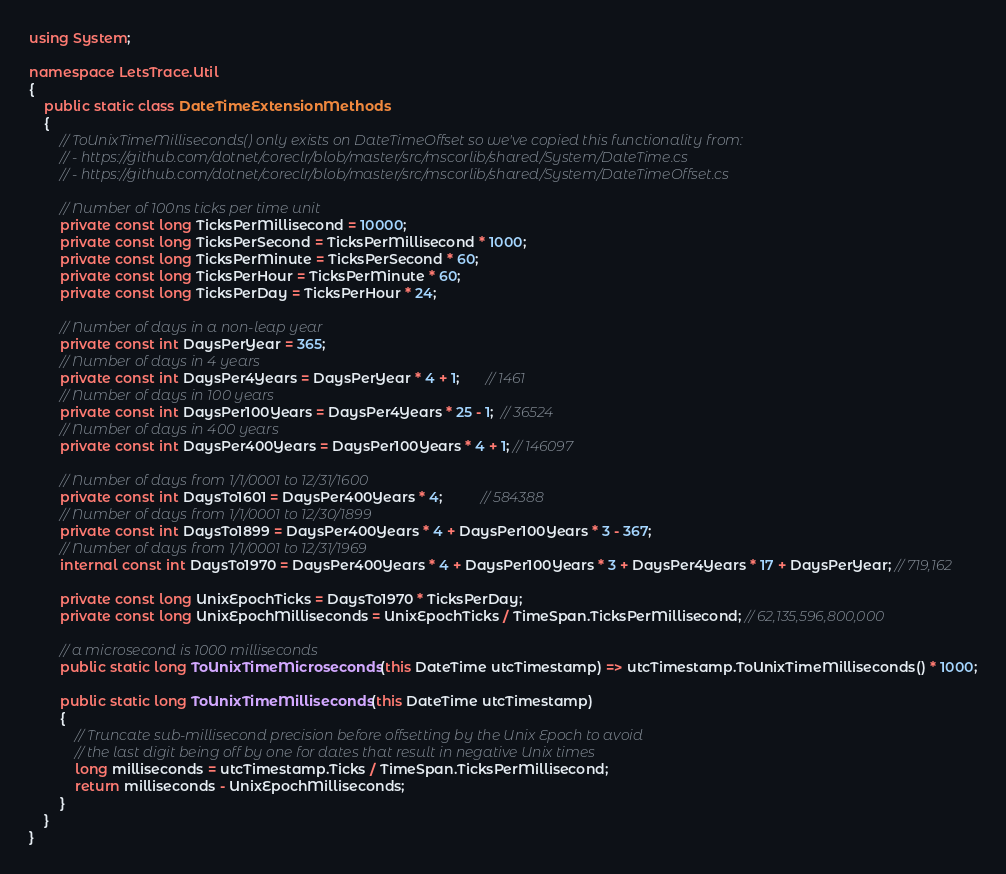<code> <loc_0><loc_0><loc_500><loc_500><_C#_>using System;

namespace LetsTrace.Util
{
    public static class DateTimeExtensionMethods
    {
        // ToUnixTimeMilliseconds() only exists on DateTimeOffset so we've copied this functionality from:
        // - https://github.com/dotnet/coreclr/blob/master/src/mscorlib/shared/System/DateTime.cs
        // - https://github.com/dotnet/coreclr/blob/master/src/mscorlib/shared/System/DateTimeOffset.cs

        // Number of 100ns ticks per time unit
        private const long TicksPerMillisecond = 10000;
        private const long TicksPerSecond = TicksPerMillisecond * 1000;
        private const long TicksPerMinute = TicksPerSecond * 60;
        private const long TicksPerHour = TicksPerMinute * 60;
        private const long TicksPerDay = TicksPerHour * 24;

        // Number of days in a non-leap year
        private const int DaysPerYear = 365;
        // Number of days in 4 years
        private const int DaysPer4Years = DaysPerYear * 4 + 1;       // 1461
        // Number of days in 100 years
        private const int DaysPer100Years = DaysPer4Years * 25 - 1;  // 36524
        // Number of days in 400 years
        private const int DaysPer400Years = DaysPer100Years * 4 + 1; // 146097

        // Number of days from 1/1/0001 to 12/31/1600
        private const int DaysTo1601 = DaysPer400Years * 4;          // 584388
        // Number of days from 1/1/0001 to 12/30/1899
        private const int DaysTo1899 = DaysPer400Years * 4 + DaysPer100Years * 3 - 367;
        // Number of days from 1/1/0001 to 12/31/1969
        internal const int DaysTo1970 = DaysPer400Years * 4 + DaysPer100Years * 3 + DaysPer4Years * 17 + DaysPerYear; // 719,162

        private const long UnixEpochTicks = DaysTo1970 * TicksPerDay;
        private const long UnixEpochMilliseconds = UnixEpochTicks / TimeSpan.TicksPerMillisecond; // 62,135,596,800,000

        // a microsecond is 1000 milliseconds
        public static long ToUnixTimeMicroseconds(this DateTime utcTimestamp) => utcTimestamp.ToUnixTimeMilliseconds() * 1000;

        public static long ToUnixTimeMilliseconds(this DateTime utcTimestamp)
        {
            // Truncate sub-millisecond precision before offsetting by the Unix Epoch to avoid
            // the last digit being off by one for dates that result in negative Unix times
            long milliseconds = utcTimestamp.Ticks / TimeSpan.TicksPerMillisecond;
            return milliseconds - UnixEpochMilliseconds;
        }
    }
}
</code> 